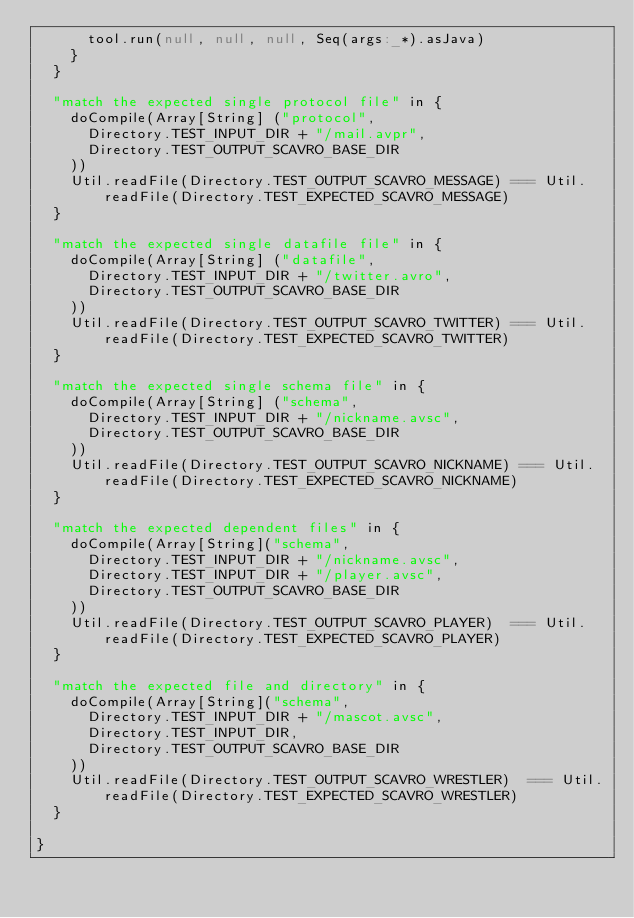Convert code to text. <code><loc_0><loc_0><loc_500><loc_500><_Scala_>      tool.run(null, null, null, Seq(args:_*).asJava)
    }
  }
  
  "match the expected single protocol file" in {
    doCompile(Array[String] ("protocol",
      Directory.TEST_INPUT_DIR + "/mail.avpr",
      Directory.TEST_OUTPUT_SCAVRO_BASE_DIR
    ))
    Util.readFile(Directory.TEST_OUTPUT_SCAVRO_MESSAGE) === Util.readFile(Directory.TEST_EXPECTED_SCAVRO_MESSAGE)
  }

  "match the expected single datafile file" in {
    doCompile(Array[String] ("datafile",
      Directory.TEST_INPUT_DIR + "/twitter.avro",
      Directory.TEST_OUTPUT_SCAVRO_BASE_DIR
    ))
    Util.readFile(Directory.TEST_OUTPUT_SCAVRO_TWITTER) === Util.readFile(Directory.TEST_EXPECTED_SCAVRO_TWITTER)
  }

  "match the expected single schema file" in {
    doCompile(Array[String] ("schema",
      Directory.TEST_INPUT_DIR + "/nickname.avsc",
      Directory.TEST_OUTPUT_SCAVRO_BASE_DIR
    ))
    Util.readFile(Directory.TEST_OUTPUT_SCAVRO_NICKNAME) === Util.readFile(Directory.TEST_EXPECTED_SCAVRO_NICKNAME)
  }

  "match the expected dependent files" in {
    doCompile(Array[String]("schema",
      Directory.TEST_INPUT_DIR + "/nickname.avsc",
      Directory.TEST_INPUT_DIR + "/player.avsc",
      Directory.TEST_OUTPUT_SCAVRO_BASE_DIR
    ))
    Util.readFile(Directory.TEST_OUTPUT_SCAVRO_PLAYER)  === Util.readFile(Directory.TEST_EXPECTED_SCAVRO_PLAYER)
  }

  "match the expected file and directory" in {
    doCompile(Array[String]("schema",
      Directory.TEST_INPUT_DIR + "/mascot.avsc",
      Directory.TEST_INPUT_DIR,
      Directory.TEST_OUTPUT_SCAVRO_BASE_DIR
    ))
    Util.readFile(Directory.TEST_OUTPUT_SCAVRO_WRESTLER)  === Util.readFile(Directory.TEST_EXPECTED_SCAVRO_WRESTLER)
  }

}</code> 